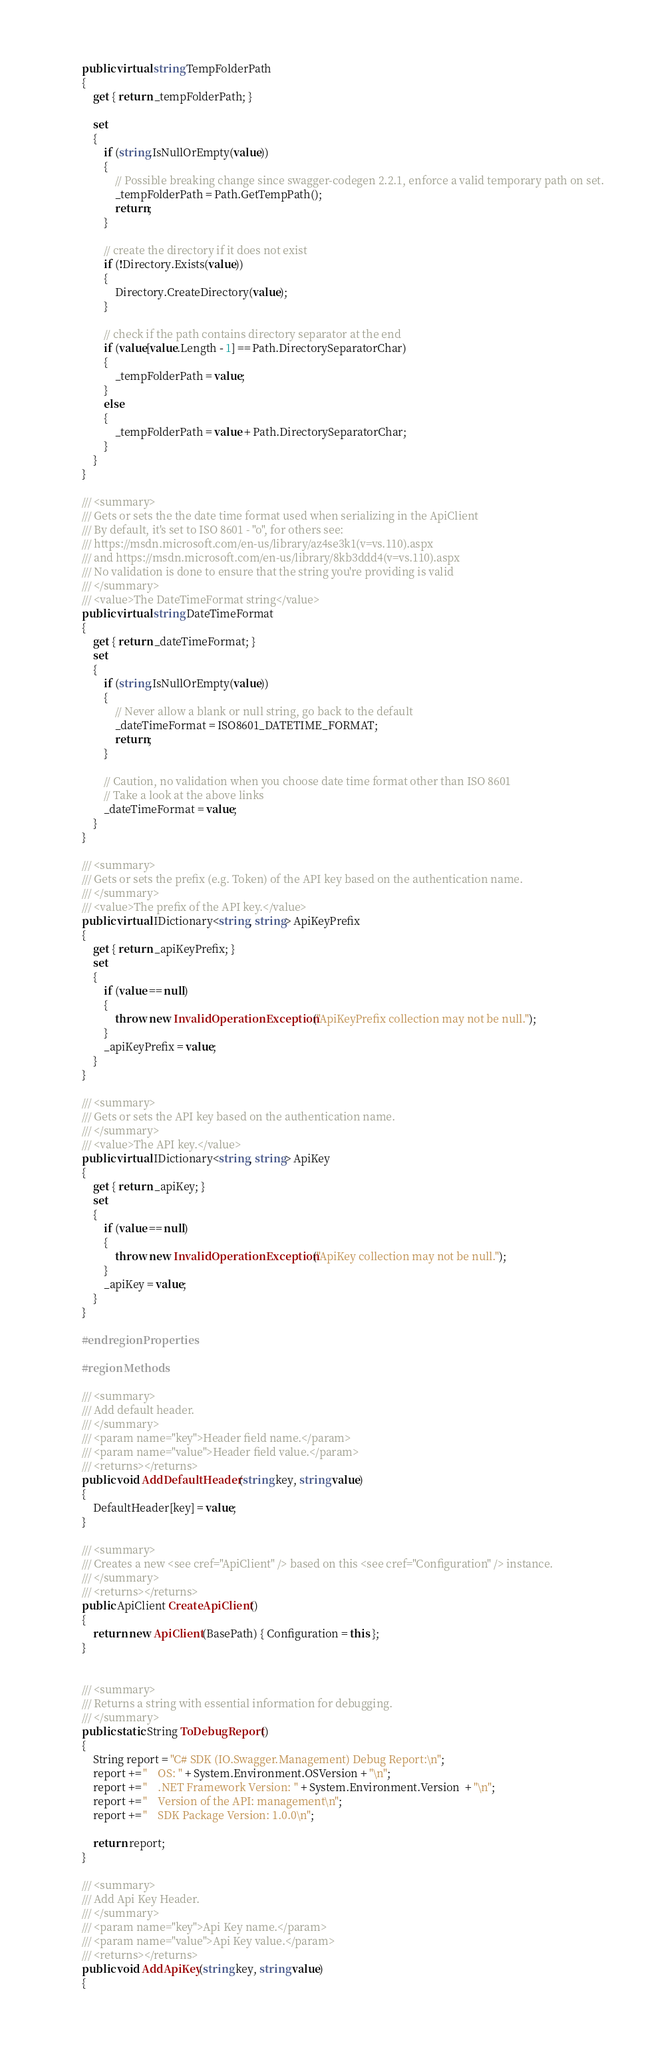Convert code to text. <code><loc_0><loc_0><loc_500><loc_500><_C#_>        public virtual string TempFolderPath
        {
            get { return _tempFolderPath; }

            set
            {
                if (string.IsNullOrEmpty(value))
                {
                    // Possible breaking change since swagger-codegen 2.2.1, enforce a valid temporary path on set.
                    _tempFolderPath = Path.GetTempPath();
                    return;
                }

                // create the directory if it does not exist
                if (!Directory.Exists(value))
                {
                    Directory.CreateDirectory(value);
                }

                // check if the path contains directory separator at the end
                if (value[value.Length - 1] == Path.DirectorySeparatorChar)
                {
                    _tempFolderPath = value;
                }
                else
                {
                    _tempFolderPath = value + Path.DirectorySeparatorChar;
                }
            }
        }

        /// <summary>
        /// Gets or sets the the date time format used when serializing in the ApiClient
        /// By default, it's set to ISO 8601 - "o", for others see:
        /// https://msdn.microsoft.com/en-us/library/az4se3k1(v=vs.110).aspx
        /// and https://msdn.microsoft.com/en-us/library/8kb3ddd4(v=vs.110).aspx
        /// No validation is done to ensure that the string you're providing is valid
        /// </summary>
        /// <value>The DateTimeFormat string</value>
        public virtual string DateTimeFormat
        {
            get { return _dateTimeFormat; }
            set
            {
                if (string.IsNullOrEmpty(value))
                {
                    // Never allow a blank or null string, go back to the default
                    _dateTimeFormat = ISO8601_DATETIME_FORMAT;
                    return;
                }

                // Caution, no validation when you choose date time format other than ISO 8601
                // Take a look at the above links
                _dateTimeFormat = value;
            }
        }

        /// <summary>
        /// Gets or sets the prefix (e.g. Token) of the API key based on the authentication name.
        /// </summary>
        /// <value>The prefix of the API key.</value>
        public virtual IDictionary<string, string> ApiKeyPrefix
        {
            get { return _apiKeyPrefix; }
            set
            {
                if (value == null)
                {
                    throw new InvalidOperationException("ApiKeyPrefix collection may not be null.");
                }
                _apiKeyPrefix = value;
            }
        }

        /// <summary>
        /// Gets or sets the API key based on the authentication name.
        /// </summary>
        /// <value>The API key.</value>
        public virtual IDictionary<string, string> ApiKey
        {
            get { return _apiKey; }
            set
            {
                if (value == null)
                {
                    throw new InvalidOperationException("ApiKey collection may not be null.");
                }
                _apiKey = value;
            }
        }

        #endregion Properties

        #region Methods

        /// <summary>
        /// Add default header.
        /// </summary>
        /// <param name="key">Header field name.</param>
        /// <param name="value">Header field value.</param>
        /// <returns></returns>
        public void AddDefaultHeader(string key, string value)
        {
            DefaultHeader[key] = value;
        }

        /// <summary>
        /// Creates a new <see cref="ApiClient" /> based on this <see cref="Configuration" /> instance.
        /// </summary>
        /// <returns></returns>
        public ApiClient CreateApiClient()
        {
            return new ApiClient(BasePath) { Configuration = this };
        }


        /// <summary>
        /// Returns a string with essential information for debugging.
        /// </summary>
        public static String ToDebugReport()
        {
            String report = "C# SDK (IO.Swagger.Management) Debug Report:\n";
            report += "    OS: " + System.Environment.OSVersion + "\n";
            report += "    .NET Framework Version: " + System.Environment.Version  + "\n";
            report += "    Version of the API: management\n";
            report += "    SDK Package Version: 1.0.0\n";

            return report;
        }

        /// <summary>
        /// Add Api Key Header.
        /// </summary>
        /// <param name="key">Api Key name.</param>
        /// <param name="value">Api Key value.</param>
        /// <returns></returns>
        public void AddApiKey(string key, string value)
        {</code> 